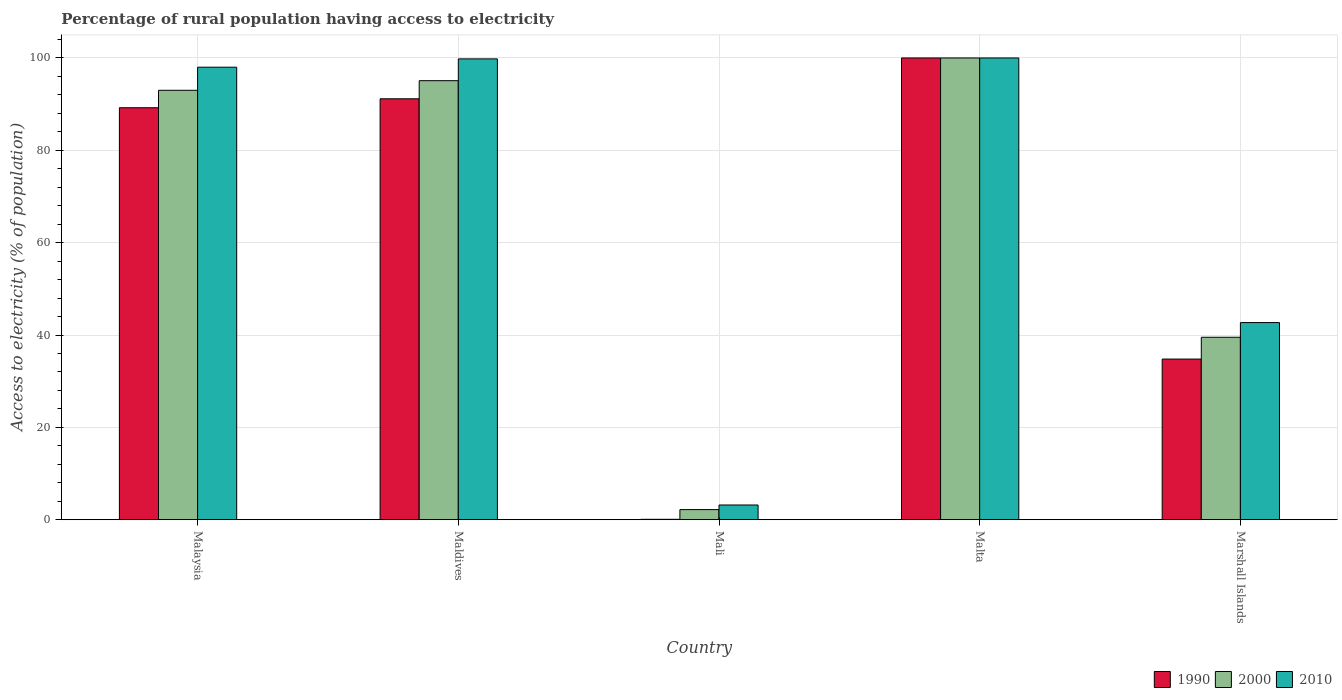How many different coloured bars are there?
Keep it short and to the point. 3. Are the number of bars per tick equal to the number of legend labels?
Keep it short and to the point. Yes. Are the number of bars on each tick of the X-axis equal?
Make the answer very short. Yes. How many bars are there on the 1st tick from the left?
Give a very brief answer. 3. How many bars are there on the 2nd tick from the right?
Make the answer very short. 3. What is the label of the 5th group of bars from the left?
Offer a very short reply. Marshall Islands. In how many cases, is the number of bars for a given country not equal to the number of legend labels?
Provide a succinct answer. 0. Across all countries, what is the maximum percentage of rural population having access to electricity in 2010?
Provide a short and direct response. 100. Across all countries, what is the minimum percentage of rural population having access to electricity in 2010?
Give a very brief answer. 3.2. In which country was the percentage of rural population having access to electricity in 2010 maximum?
Provide a short and direct response. Malta. In which country was the percentage of rural population having access to electricity in 1990 minimum?
Provide a short and direct response. Mali. What is the total percentage of rural population having access to electricity in 1990 in the graph?
Make the answer very short. 315.28. What is the difference between the percentage of rural population having access to electricity in 2010 in Malaysia and that in Marshall Islands?
Provide a succinct answer. 55.3. What is the average percentage of rural population having access to electricity in 2000 per country?
Keep it short and to the point. 65.96. What is the difference between the percentage of rural population having access to electricity of/in 2010 and percentage of rural population having access to electricity of/in 2000 in Marshall Islands?
Keep it short and to the point. 3.18. What is the ratio of the percentage of rural population having access to electricity in 2010 in Mali to that in Malta?
Your answer should be very brief. 0.03. What is the difference between the highest and the second highest percentage of rural population having access to electricity in 1990?
Offer a terse response. -1.94. What is the difference between the highest and the lowest percentage of rural population having access to electricity in 2000?
Your answer should be very brief. 97.8. In how many countries, is the percentage of rural population having access to electricity in 1990 greater than the average percentage of rural population having access to electricity in 1990 taken over all countries?
Provide a short and direct response. 3. Is the sum of the percentage of rural population having access to electricity in 2000 in Mali and Malta greater than the maximum percentage of rural population having access to electricity in 2010 across all countries?
Keep it short and to the point. Yes. What does the 1st bar from the left in Marshall Islands represents?
Offer a very short reply. 1990. What does the 3rd bar from the right in Mali represents?
Offer a terse response. 1990. Is it the case that in every country, the sum of the percentage of rural population having access to electricity in 1990 and percentage of rural population having access to electricity in 2010 is greater than the percentage of rural population having access to electricity in 2000?
Make the answer very short. Yes. What is the difference between two consecutive major ticks on the Y-axis?
Provide a succinct answer. 20. Where does the legend appear in the graph?
Ensure brevity in your answer.  Bottom right. How many legend labels are there?
Your response must be concise. 3. How are the legend labels stacked?
Your answer should be very brief. Horizontal. What is the title of the graph?
Your answer should be very brief. Percentage of rural population having access to electricity. Does "2010" appear as one of the legend labels in the graph?
Ensure brevity in your answer.  Yes. What is the label or title of the Y-axis?
Keep it short and to the point. Access to electricity (% of population). What is the Access to electricity (% of population) of 1990 in Malaysia?
Offer a terse response. 89.22. What is the Access to electricity (% of population) in 2000 in Malaysia?
Offer a very short reply. 93. What is the Access to electricity (% of population) of 2010 in Malaysia?
Your response must be concise. 98. What is the Access to electricity (% of population) of 1990 in Maldives?
Give a very brief answer. 91.16. What is the Access to electricity (% of population) in 2000 in Maldives?
Give a very brief answer. 95.08. What is the Access to electricity (% of population) of 2010 in Maldives?
Your answer should be very brief. 99.8. What is the Access to electricity (% of population) in 1990 in Mali?
Your answer should be compact. 0.1. What is the Access to electricity (% of population) in 1990 in Malta?
Offer a terse response. 100. What is the Access to electricity (% of population) of 2000 in Malta?
Make the answer very short. 100. What is the Access to electricity (% of population) in 2010 in Malta?
Offer a very short reply. 100. What is the Access to electricity (% of population) in 1990 in Marshall Islands?
Provide a succinct answer. 34.8. What is the Access to electricity (% of population) of 2000 in Marshall Islands?
Your answer should be very brief. 39.52. What is the Access to electricity (% of population) of 2010 in Marshall Islands?
Your answer should be compact. 42.7. Across all countries, what is the maximum Access to electricity (% of population) in 1990?
Your answer should be compact. 100. What is the total Access to electricity (% of population) of 1990 in the graph?
Your response must be concise. 315.28. What is the total Access to electricity (% of population) of 2000 in the graph?
Keep it short and to the point. 329.8. What is the total Access to electricity (% of population) of 2010 in the graph?
Your answer should be very brief. 343.7. What is the difference between the Access to electricity (% of population) in 1990 in Malaysia and that in Maldives?
Keep it short and to the point. -1.94. What is the difference between the Access to electricity (% of population) of 2000 in Malaysia and that in Maldives?
Offer a very short reply. -2.08. What is the difference between the Access to electricity (% of population) of 1990 in Malaysia and that in Mali?
Ensure brevity in your answer.  89.12. What is the difference between the Access to electricity (% of population) in 2000 in Malaysia and that in Mali?
Provide a succinct answer. 90.8. What is the difference between the Access to electricity (% of population) in 2010 in Malaysia and that in Mali?
Offer a terse response. 94.8. What is the difference between the Access to electricity (% of population) of 1990 in Malaysia and that in Malta?
Offer a terse response. -10.78. What is the difference between the Access to electricity (% of population) of 2000 in Malaysia and that in Malta?
Provide a short and direct response. -7. What is the difference between the Access to electricity (% of population) of 2010 in Malaysia and that in Malta?
Your answer should be compact. -2. What is the difference between the Access to electricity (% of population) in 1990 in Malaysia and that in Marshall Islands?
Provide a succinct answer. 54.42. What is the difference between the Access to electricity (% of population) of 2000 in Malaysia and that in Marshall Islands?
Make the answer very short. 53.48. What is the difference between the Access to electricity (% of population) of 2010 in Malaysia and that in Marshall Islands?
Make the answer very short. 55.3. What is the difference between the Access to electricity (% of population) in 1990 in Maldives and that in Mali?
Provide a short and direct response. 91.06. What is the difference between the Access to electricity (% of population) of 2000 in Maldives and that in Mali?
Your response must be concise. 92.88. What is the difference between the Access to electricity (% of population) of 2010 in Maldives and that in Mali?
Provide a short and direct response. 96.6. What is the difference between the Access to electricity (% of population) in 1990 in Maldives and that in Malta?
Provide a succinct answer. -8.84. What is the difference between the Access to electricity (% of population) in 2000 in Maldives and that in Malta?
Your answer should be compact. -4.92. What is the difference between the Access to electricity (% of population) of 1990 in Maldives and that in Marshall Islands?
Provide a succinct answer. 56.36. What is the difference between the Access to electricity (% of population) in 2000 in Maldives and that in Marshall Islands?
Keep it short and to the point. 55.56. What is the difference between the Access to electricity (% of population) in 2010 in Maldives and that in Marshall Islands?
Provide a succinct answer. 57.1. What is the difference between the Access to electricity (% of population) in 1990 in Mali and that in Malta?
Offer a very short reply. -99.9. What is the difference between the Access to electricity (% of population) of 2000 in Mali and that in Malta?
Ensure brevity in your answer.  -97.8. What is the difference between the Access to electricity (% of population) of 2010 in Mali and that in Malta?
Your response must be concise. -96.8. What is the difference between the Access to electricity (% of population) in 1990 in Mali and that in Marshall Islands?
Your answer should be very brief. -34.7. What is the difference between the Access to electricity (% of population) in 2000 in Mali and that in Marshall Islands?
Keep it short and to the point. -37.32. What is the difference between the Access to electricity (% of population) of 2010 in Mali and that in Marshall Islands?
Make the answer very short. -39.5. What is the difference between the Access to electricity (% of population) of 1990 in Malta and that in Marshall Islands?
Keep it short and to the point. 65.2. What is the difference between the Access to electricity (% of population) of 2000 in Malta and that in Marshall Islands?
Offer a terse response. 60.48. What is the difference between the Access to electricity (% of population) of 2010 in Malta and that in Marshall Islands?
Make the answer very short. 57.3. What is the difference between the Access to electricity (% of population) of 1990 in Malaysia and the Access to electricity (% of population) of 2000 in Maldives?
Provide a short and direct response. -5.86. What is the difference between the Access to electricity (% of population) of 1990 in Malaysia and the Access to electricity (% of population) of 2010 in Maldives?
Keep it short and to the point. -10.58. What is the difference between the Access to electricity (% of population) in 2000 in Malaysia and the Access to electricity (% of population) in 2010 in Maldives?
Provide a succinct answer. -6.8. What is the difference between the Access to electricity (% of population) of 1990 in Malaysia and the Access to electricity (% of population) of 2000 in Mali?
Keep it short and to the point. 87.02. What is the difference between the Access to electricity (% of population) of 1990 in Malaysia and the Access to electricity (% of population) of 2010 in Mali?
Offer a very short reply. 86.02. What is the difference between the Access to electricity (% of population) in 2000 in Malaysia and the Access to electricity (% of population) in 2010 in Mali?
Keep it short and to the point. 89.8. What is the difference between the Access to electricity (% of population) in 1990 in Malaysia and the Access to electricity (% of population) in 2000 in Malta?
Ensure brevity in your answer.  -10.78. What is the difference between the Access to electricity (% of population) in 1990 in Malaysia and the Access to electricity (% of population) in 2010 in Malta?
Provide a short and direct response. -10.78. What is the difference between the Access to electricity (% of population) of 1990 in Malaysia and the Access to electricity (% of population) of 2000 in Marshall Islands?
Offer a terse response. 49.7. What is the difference between the Access to electricity (% of population) of 1990 in Malaysia and the Access to electricity (% of population) of 2010 in Marshall Islands?
Your response must be concise. 46.52. What is the difference between the Access to electricity (% of population) in 2000 in Malaysia and the Access to electricity (% of population) in 2010 in Marshall Islands?
Your response must be concise. 50.3. What is the difference between the Access to electricity (% of population) in 1990 in Maldives and the Access to electricity (% of population) in 2000 in Mali?
Your answer should be very brief. 88.96. What is the difference between the Access to electricity (% of population) of 1990 in Maldives and the Access to electricity (% of population) of 2010 in Mali?
Make the answer very short. 87.96. What is the difference between the Access to electricity (% of population) of 2000 in Maldives and the Access to electricity (% of population) of 2010 in Mali?
Ensure brevity in your answer.  91.88. What is the difference between the Access to electricity (% of population) of 1990 in Maldives and the Access to electricity (% of population) of 2000 in Malta?
Offer a very short reply. -8.84. What is the difference between the Access to electricity (% of population) in 1990 in Maldives and the Access to electricity (% of population) in 2010 in Malta?
Your answer should be compact. -8.84. What is the difference between the Access to electricity (% of population) of 2000 in Maldives and the Access to electricity (% of population) of 2010 in Malta?
Your answer should be very brief. -4.92. What is the difference between the Access to electricity (% of population) in 1990 in Maldives and the Access to electricity (% of population) in 2000 in Marshall Islands?
Give a very brief answer. 51.64. What is the difference between the Access to electricity (% of population) in 1990 in Maldives and the Access to electricity (% of population) in 2010 in Marshall Islands?
Your answer should be compact. 48.46. What is the difference between the Access to electricity (% of population) of 2000 in Maldives and the Access to electricity (% of population) of 2010 in Marshall Islands?
Your answer should be compact. 52.38. What is the difference between the Access to electricity (% of population) in 1990 in Mali and the Access to electricity (% of population) in 2000 in Malta?
Ensure brevity in your answer.  -99.9. What is the difference between the Access to electricity (% of population) in 1990 in Mali and the Access to electricity (% of population) in 2010 in Malta?
Keep it short and to the point. -99.9. What is the difference between the Access to electricity (% of population) of 2000 in Mali and the Access to electricity (% of population) of 2010 in Malta?
Offer a very short reply. -97.8. What is the difference between the Access to electricity (% of population) of 1990 in Mali and the Access to electricity (% of population) of 2000 in Marshall Islands?
Provide a short and direct response. -39.42. What is the difference between the Access to electricity (% of population) in 1990 in Mali and the Access to electricity (% of population) in 2010 in Marshall Islands?
Ensure brevity in your answer.  -42.6. What is the difference between the Access to electricity (% of population) in 2000 in Mali and the Access to electricity (% of population) in 2010 in Marshall Islands?
Provide a succinct answer. -40.5. What is the difference between the Access to electricity (% of population) of 1990 in Malta and the Access to electricity (% of population) of 2000 in Marshall Islands?
Offer a very short reply. 60.48. What is the difference between the Access to electricity (% of population) of 1990 in Malta and the Access to electricity (% of population) of 2010 in Marshall Islands?
Make the answer very short. 57.3. What is the difference between the Access to electricity (% of population) in 2000 in Malta and the Access to electricity (% of population) in 2010 in Marshall Islands?
Your answer should be compact. 57.3. What is the average Access to electricity (% of population) of 1990 per country?
Offer a very short reply. 63.06. What is the average Access to electricity (% of population) in 2000 per country?
Give a very brief answer. 65.96. What is the average Access to electricity (% of population) of 2010 per country?
Provide a succinct answer. 68.74. What is the difference between the Access to electricity (% of population) of 1990 and Access to electricity (% of population) of 2000 in Malaysia?
Keep it short and to the point. -3.78. What is the difference between the Access to electricity (% of population) in 1990 and Access to electricity (% of population) in 2010 in Malaysia?
Keep it short and to the point. -8.78. What is the difference between the Access to electricity (% of population) in 1990 and Access to electricity (% of population) in 2000 in Maldives?
Offer a very short reply. -3.92. What is the difference between the Access to electricity (% of population) in 1990 and Access to electricity (% of population) in 2010 in Maldives?
Offer a terse response. -8.64. What is the difference between the Access to electricity (% of population) of 2000 and Access to electricity (% of population) of 2010 in Maldives?
Your answer should be compact. -4.72. What is the difference between the Access to electricity (% of population) in 1990 and Access to electricity (% of population) in 2000 in Mali?
Keep it short and to the point. -2.1. What is the difference between the Access to electricity (% of population) in 1990 and Access to electricity (% of population) in 2000 in Malta?
Make the answer very short. 0. What is the difference between the Access to electricity (% of population) in 1990 and Access to electricity (% of population) in 2010 in Malta?
Provide a short and direct response. 0. What is the difference between the Access to electricity (% of population) of 2000 and Access to electricity (% of population) of 2010 in Malta?
Offer a very short reply. 0. What is the difference between the Access to electricity (% of population) in 1990 and Access to electricity (% of population) in 2000 in Marshall Islands?
Offer a very short reply. -4.72. What is the difference between the Access to electricity (% of population) in 1990 and Access to electricity (% of population) in 2010 in Marshall Islands?
Give a very brief answer. -7.9. What is the difference between the Access to electricity (% of population) of 2000 and Access to electricity (% of population) of 2010 in Marshall Islands?
Provide a short and direct response. -3.18. What is the ratio of the Access to electricity (% of population) of 1990 in Malaysia to that in Maldives?
Your answer should be compact. 0.98. What is the ratio of the Access to electricity (% of population) in 2000 in Malaysia to that in Maldives?
Offer a very short reply. 0.98. What is the ratio of the Access to electricity (% of population) of 2010 in Malaysia to that in Maldives?
Make the answer very short. 0.98. What is the ratio of the Access to electricity (% of population) in 1990 in Malaysia to that in Mali?
Your response must be concise. 892.2. What is the ratio of the Access to electricity (% of population) in 2000 in Malaysia to that in Mali?
Your answer should be compact. 42.27. What is the ratio of the Access to electricity (% of population) in 2010 in Malaysia to that in Mali?
Keep it short and to the point. 30.62. What is the ratio of the Access to electricity (% of population) of 1990 in Malaysia to that in Malta?
Provide a succinct answer. 0.89. What is the ratio of the Access to electricity (% of population) of 2000 in Malaysia to that in Malta?
Your response must be concise. 0.93. What is the ratio of the Access to electricity (% of population) of 1990 in Malaysia to that in Marshall Islands?
Offer a very short reply. 2.56. What is the ratio of the Access to electricity (% of population) in 2000 in Malaysia to that in Marshall Islands?
Keep it short and to the point. 2.35. What is the ratio of the Access to electricity (% of population) of 2010 in Malaysia to that in Marshall Islands?
Offer a terse response. 2.3. What is the ratio of the Access to electricity (% of population) in 1990 in Maldives to that in Mali?
Your response must be concise. 911.6. What is the ratio of the Access to electricity (% of population) in 2000 in Maldives to that in Mali?
Give a very brief answer. 43.22. What is the ratio of the Access to electricity (% of population) of 2010 in Maldives to that in Mali?
Ensure brevity in your answer.  31.19. What is the ratio of the Access to electricity (% of population) in 1990 in Maldives to that in Malta?
Keep it short and to the point. 0.91. What is the ratio of the Access to electricity (% of population) in 2000 in Maldives to that in Malta?
Offer a very short reply. 0.95. What is the ratio of the Access to electricity (% of population) of 2010 in Maldives to that in Malta?
Offer a very short reply. 1. What is the ratio of the Access to electricity (% of population) in 1990 in Maldives to that in Marshall Islands?
Provide a succinct answer. 2.62. What is the ratio of the Access to electricity (% of population) in 2000 in Maldives to that in Marshall Islands?
Your answer should be very brief. 2.41. What is the ratio of the Access to electricity (% of population) in 2010 in Maldives to that in Marshall Islands?
Keep it short and to the point. 2.34. What is the ratio of the Access to electricity (% of population) in 2000 in Mali to that in Malta?
Your response must be concise. 0.02. What is the ratio of the Access to electricity (% of population) of 2010 in Mali to that in Malta?
Your response must be concise. 0.03. What is the ratio of the Access to electricity (% of population) of 1990 in Mali to that in Marshall Islands?
Your response must be concise. 0. What is the ratio of the Access to electricity (% of population) in 2000 in Mali to that in Marshall Islands?
Your answer should be very brief. 0.06. What is the ratio of the Access to electricity (% of population) of 2010 in Mali to that in Marshall Islands?
Your answer should be very brief. 0.07. What is the ratio of the Access to electricity (% of population) in 1990 in Malta to that in Marshall Islands?
Give a very brief answer. 2.87. What is the ratio of the Access to electricity (% of population) in 2000 in Malta to that in Marshall Islands?
Make the answer very short. 2.53. What is the ratio of the Access to electricity (% of population) of 2010 in Malta to that in Marshall Islands?
Your response must be concise. 2.34. What is the difference between the highest and the second highest Access to electricity (% of population) in 1990?
Make the answer very short. 8.84. What is the difference between the highest and the second highest Access to electricity (% of population) in 2000?
Provide a short and direct response. 4.92. What is the difference between the highest and the lowest Access to electricity (% of population) in 1990?
Ensure brevity in your answer.  99.9. What is the difference between the highest and the lowest Access to electricity (% of population) in 2000?
Offer a terse response. 97.8. What is the difference between the highest and the lowest Access to electricity (% of population) in 2010?
Offer a terse response. 96.8. 